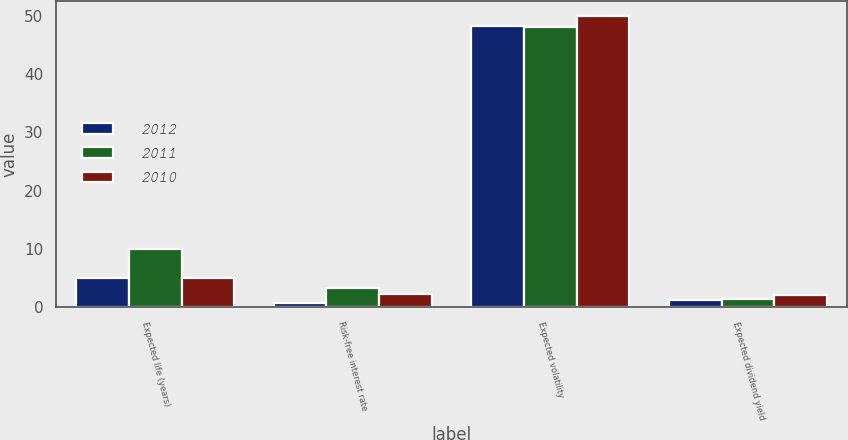<chart> <loc_0><loc_0><loc_500><loc_500><stacked_bar_chart><ecel><fcel>Expected life (years)<fcel>Risk-free interest rate<fcel>Expected volatility<fcel>Expected dividend yield<nl><fcel>2012<fcel>5<fcel>0.7<fcel>48.2<fcel>1.2<nl><fcel>2011<fcel>9.9<fcel>3.3<fcel>48<fcel>1.3<nl><fcel>2010<fcel>5<fcel>2.2<fcel>50<fcel>2<nl></chart> 